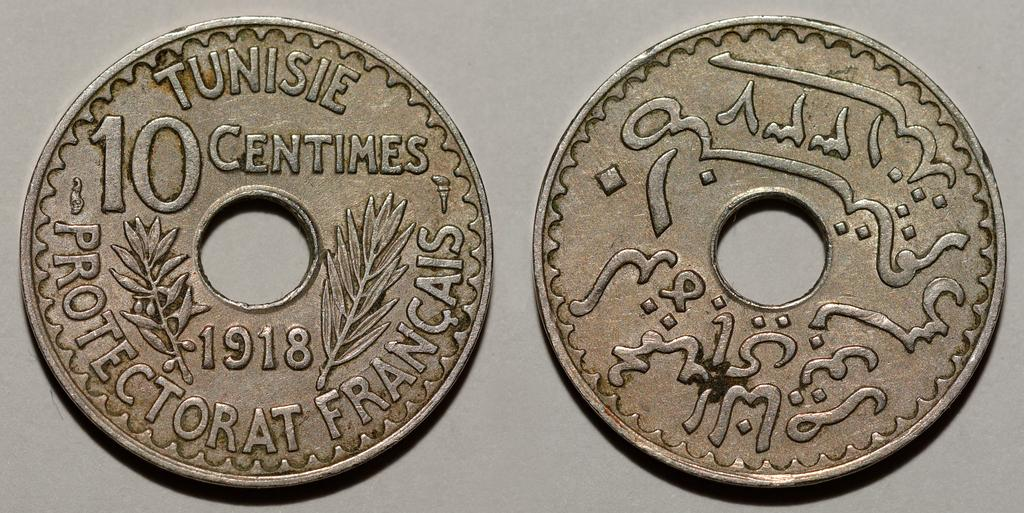Provide a one-sentence caption for the provided image. a coin with a hole in the middle and has the words Tunisie Centimes on it. 